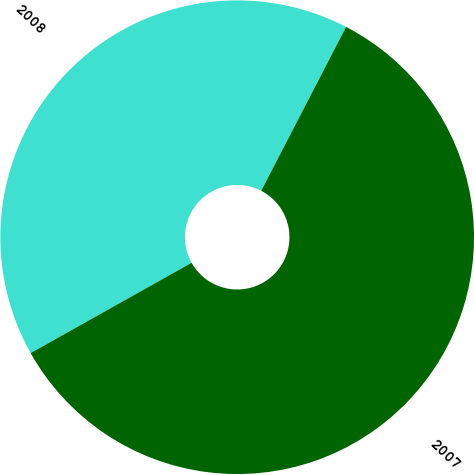<chart> <loc_0><loc_0><loc_500><loc_500><pie_chart><fcel>2008<fcel>2007<nl><fcel>40.74%<fcel>59.26%<nl></chart> 